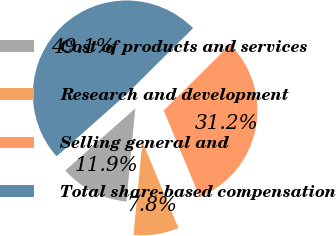<chart> <loc_0><loc_0><loc_500><loc_500><pie_chart><fcel>Cost of products and services<fcel>Research and development<fcel>Selling general and<fcel>Total share-based compensation<nl><fcel>11.92%<fcel>7.79%<fcel>31.16%<fcel>49.13%<nl></chart> 